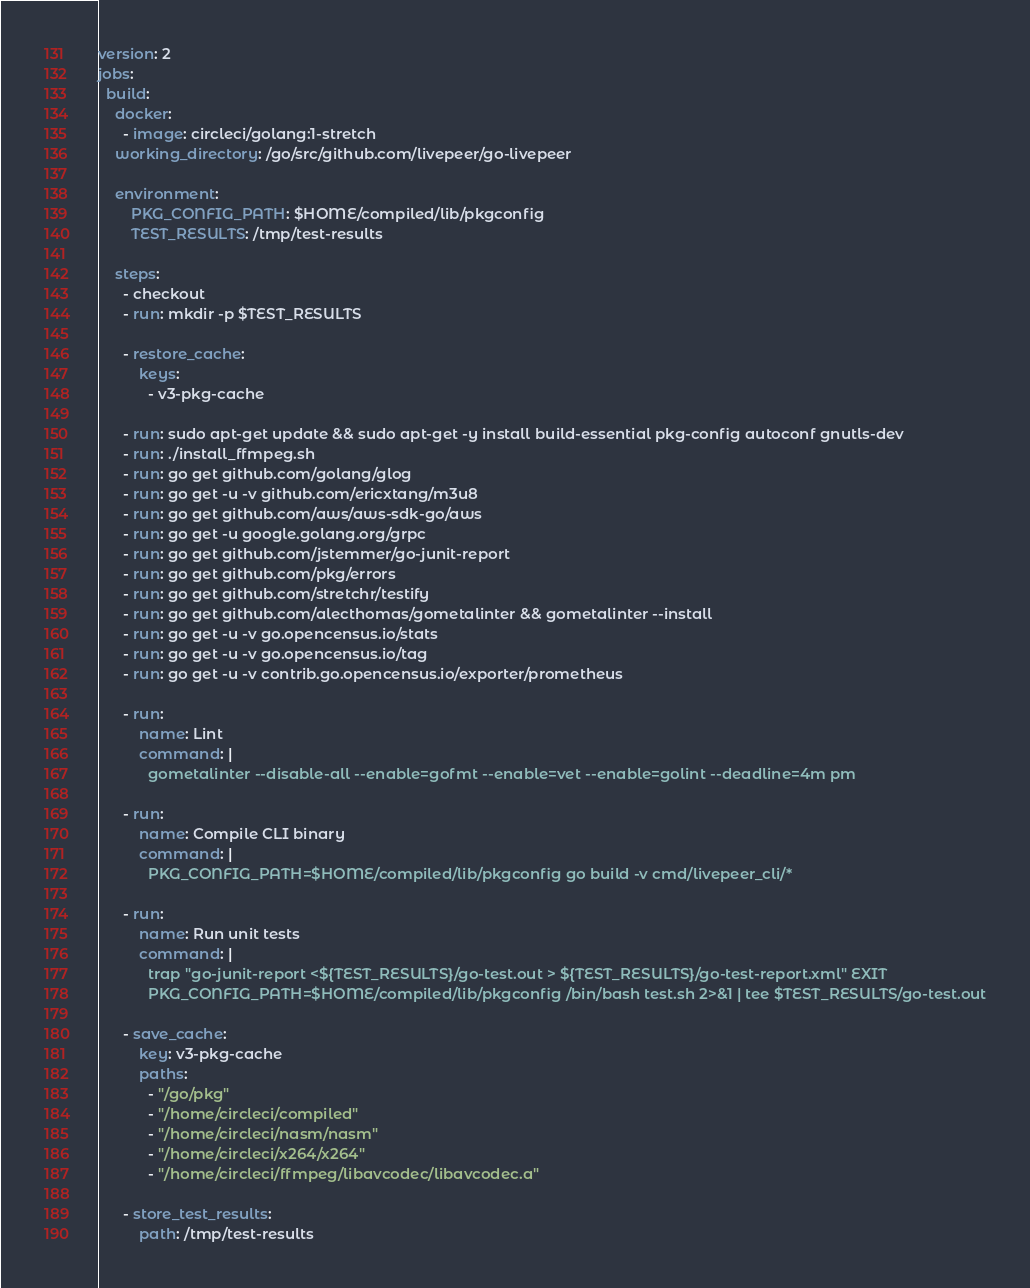Convert code to text. <code><loc_0><loc_0><loc_500><loc_500><_YAML_>version: 2
jobs:
  build:
    docker:
      - image: circleci/golang:1-stretch
    working_directory: /go/src/github.com/livepeer/go-livepeer

    environment:
        PKG_CONFIG_PATH: $HOME/compiled/lib/pkgconfig
        TEST_RESULTS: /tmp/test-results

    steps:
      - checkout
      - run: mkdir -p $TEST_RESULTS

      - restore_cache:
          keys:
            - v3-pkg-cache

      - run: sudo apt-get update && sudo apt-get -y install build-essential pkg-config autoconf gnutls-dev
      - run: ./install_ffmpeg.sh
      - run: go get github.com/golang/glog
      - run: go get -u -v github.com/ericxtang/m3u8
      - run: go get github.com/aws/aws-sdk-go/aws
      - run: go get -u google.golang.org/grpc
      - run: go get github.com/jstemmer/go-junit-report
      - run: go get github.com/pkg/errors
      - run: go get github.com/stretchr/testify
      - run: go get github.com/alecthomas/gometalinter && gometalinter --install
      - run: go get -u -v go.opencensus.io/stats
      - run: go get -u -v go.opencensus.io/tag
      - run: go get -u -v contrib.go.opencensus.io/exporter/prometheus

      - run:
          name: Lint
          command: |
            gometalinter --disable-all --enable=gofmt --enable=vet --enable=golint --deadline=4m pm

      - run:
          name: Compile CLI binary
          command: |
            PKG_CONFIG_PATH=$HOME/compiled/lib/pkgconfig go build -v cmd/livepeer_cli/*

      - run:
          name: Run unit tests
          command: |
            trap "go-junit-report <${TEST_RESULTS}/go-test.out > ${TEST_RESULTS}/go-test-report.xml" EXIT
            PKG_CONFIG_PATH=$HOME/compiled/lib/pkgconfig /bin/bash test.sh 2>&1 | tee $TEST_RESULTS/go-test.out

      - save_cache:
          key: v3-pkg-cache
          paths:
            - "/go/pkg"
            - "/home/circleci/compiled"
            - "/home/circleci/nasm/nasm"
            - "/home/circleci/x264/x264"
            - "/home/circleci/ffmpeg/libavcodec/libavcodec.a"

      - store_test_results:
          path: /tmp/test-results
</code> 